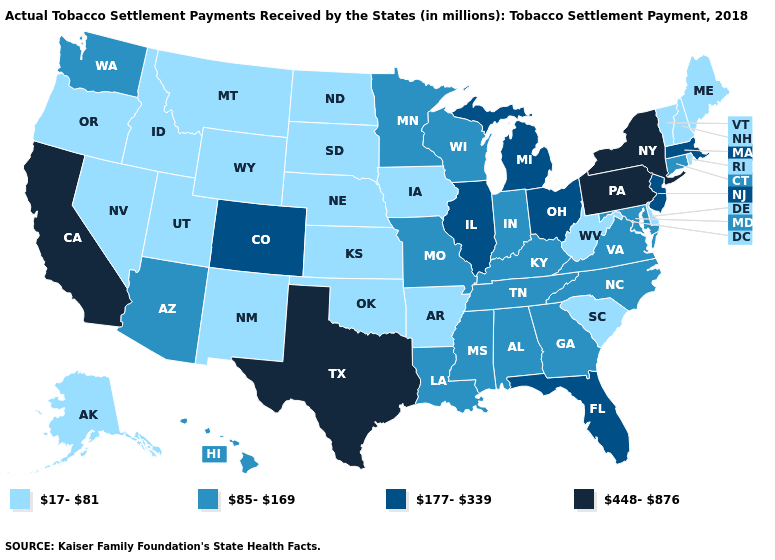Does New York have the highest value in the USA?
Concise answer only. Yes. Is the legend a continuous bar?
Concise answer only. No. Name the states that have a value in the range 177-339?
Concise answer only. Colorado, Florida, Illinois, Massachusetts, Michigan, New Jersey, Ohio. What is the lowest value in the South?
Write a very short answer. 17-81. What is the value of Tennessee?
Concise answer only. 85-169. What is the value of Michigan?
Concise answer only. 177-339. Name the states that have a value in the range 177-339?
Keep it brief. Colorado, Florida, Illinois, Massachusetts, Michigan, New Jersey, Ohio. Does Washington have the highest value in the USA?
Give a very brief answer. No. Which states hav the highest value in the West?
Quick response, please. California. How many symbols are there in the legend?
Short answer required. 4. Name the states that have a value in the range 448-876?
Quick response, please. California, New York, Pennsylvania, Texas. Among the states that border West Virginia , which have the highest value?
Short answer required. Pennsylvania. What is the value of Oregon?
Quick response, please. 17-81. Among the states that border Oklahoma , does New Mexico have the highest value?
Short answer required. No. 